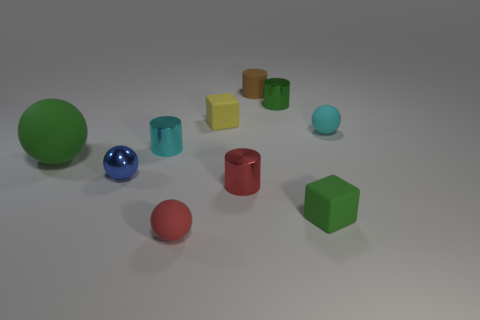Subtract all large rubber spheres. How many spheres are left? 3 Subtract all green cylinders. How many cylinders are left? 3 Subtract 1 cylinders. How many cylinders are left? 3 Subtract all cylinders. How many objects are left? 6 Subtract all yellow cylinders. Subtract all purple blocks. How many cylinders are left? 4 Subtract all yellow metal objects. Subtract all small blue shiny balls. How many objects are left? 9 Add 5 big spheres. How many big spheres are left? 6 Add 2 tiny red rubber balls. How many tiny red rubber balls exist? 3 Subtract 1 brown cylinders. How many objects are left? 9 